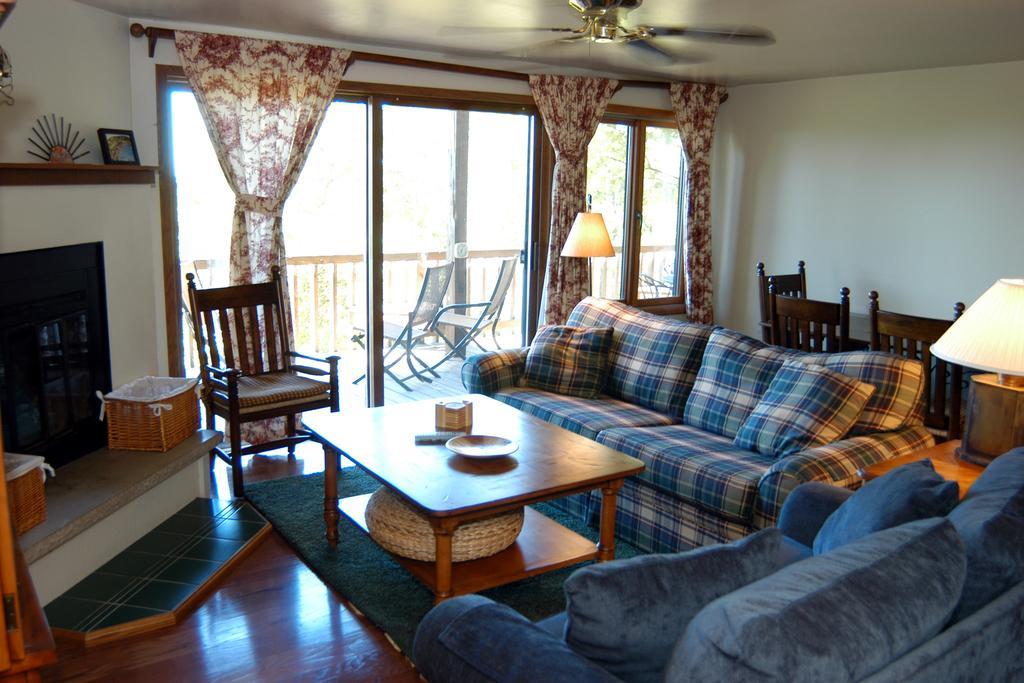Could you give a brief overview of what you see in this image? In this image I can see there is a sofa, a table, a chair on the floor. I can also see there is a curtain, a fan, a white color wall, a lamp and a fireplace on the floor. 